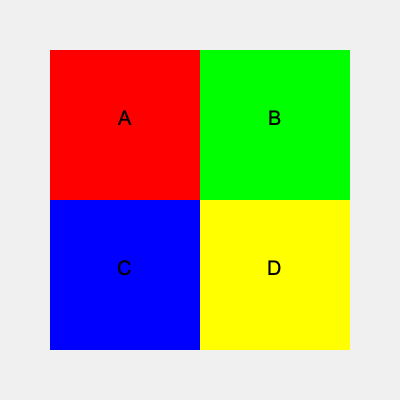Given the color-coded map of four districts (A, B, C, and D), which district has the highest voter turnout if red represents the highest turnout, followed by green, blue, and yellow in descending order? To determine which district has the highest voter turnout, we need to analyze the color-coding of the map:

1. Identify the color representation:
   - Red: Highest turnout
   - Green: Second highest turnout
   - Blue: Third highest turnout
   - Yellow: Lowest turnout

2. Examine each district's color:
   - District A: Red
   - District B: Green
   - District C: Blue
   - District D: Yellow

3. Compare the colors:
   - Red represents the highest turnout
   - District A is the only district colored red

Therefore, District A has the highest voter turnout according to the color-coded map.
Answer: District A 